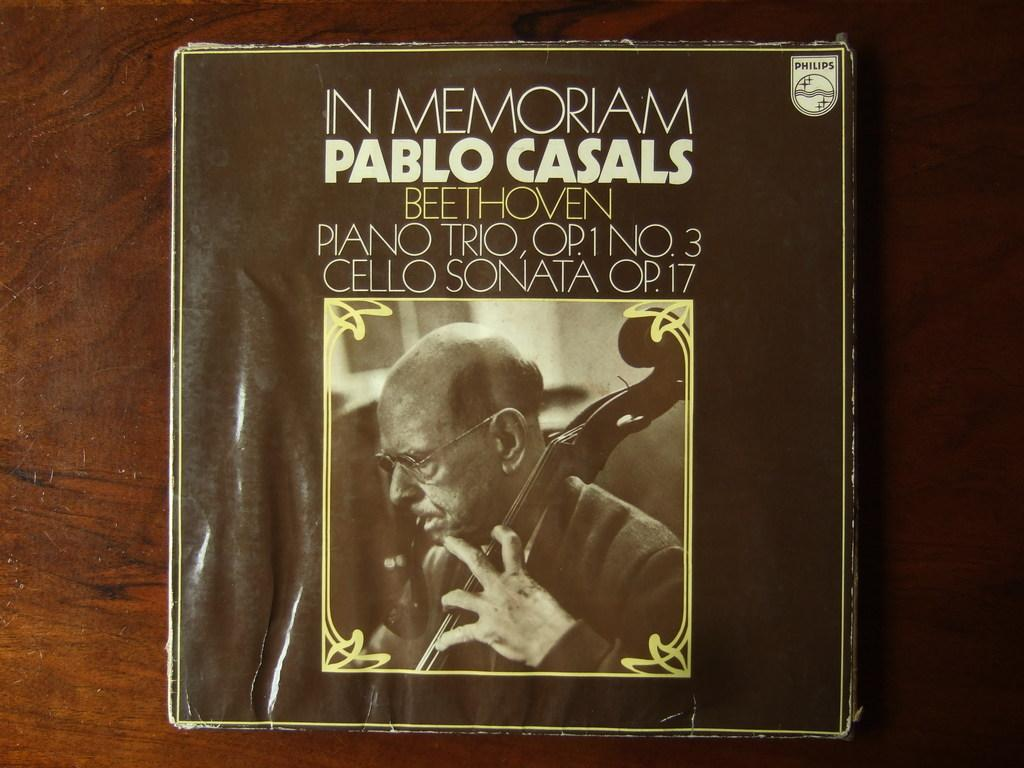Provide a one-sentence caption for the provided image. A record cover for an album that is in memory of Pablo Casals. 